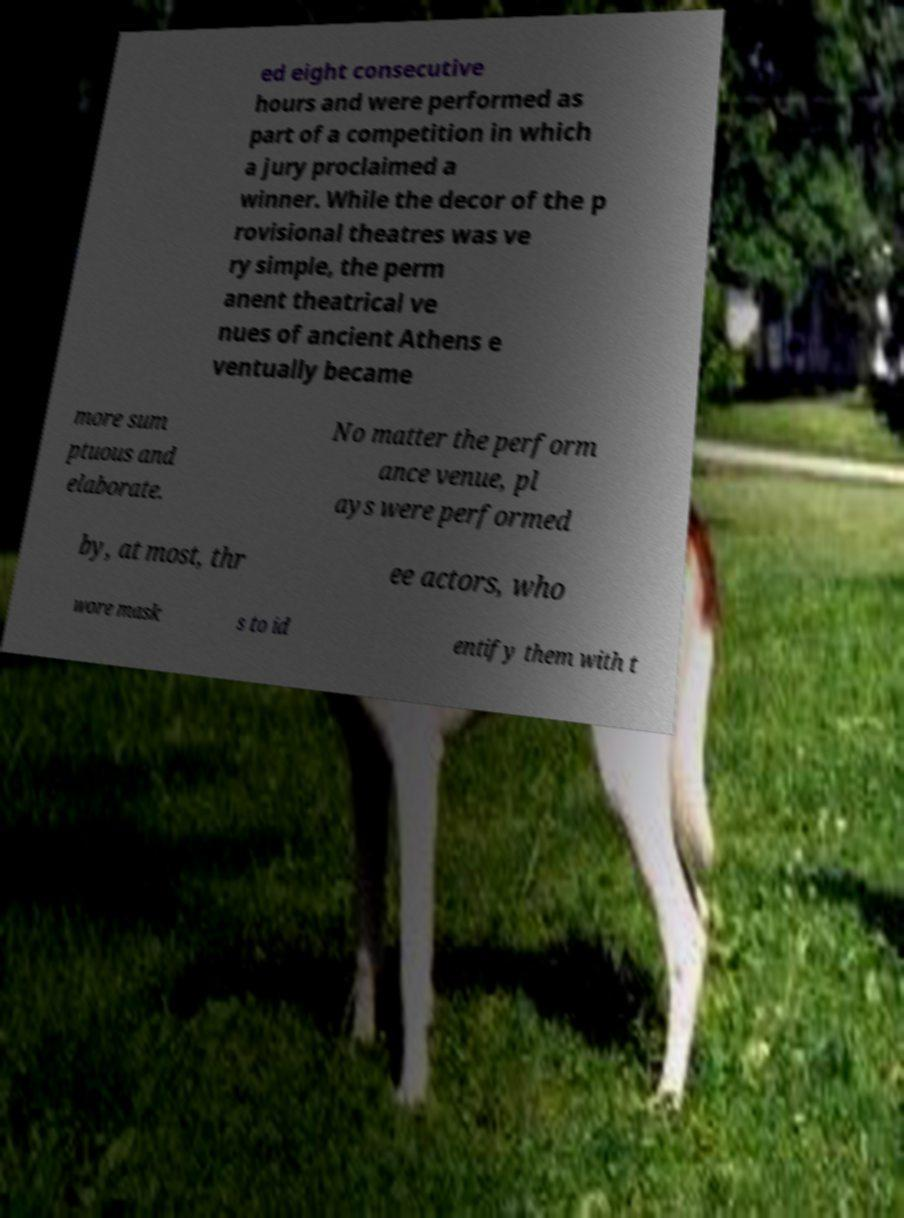I need the written content from this picture converted into text. Can you do that? ed eight consecutive hours and were performed as part of a competition in which a jury proclaimed a winner. While the decor of the p rovisional theatres was ve ry simple, the perm anent theatrical ve nues of ancient Athens e ventually became more sum ptuous and elaborate. No matter the perform ance venue, pl ays were performed by, at most, thr ee actors, who wore mask s to id entify them with t 